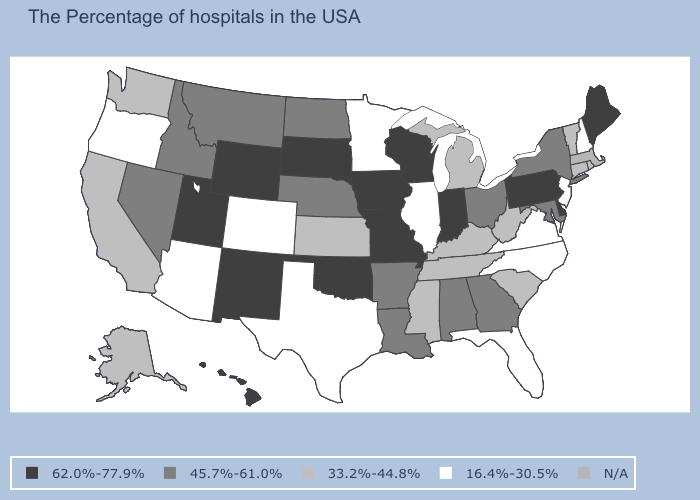Name the states that have a value in the range 45.7%-61.0%?
Be succinct. New York, Maryland, Ohio, Georgia, Alabama, Louisiana, Arkansas, Nebraska, North Dakota, Montana, Idaho, Nevada. Which states have the lowest value in the USA?
Answer briefly. New Hampshire, New Jersey, Virginia, North Carolina, Florida, Illinois, Minnesota, Texas, Colorado, Arizona, Oregon. Which states have the lowest value in the USA?
Short answer required. New Hampshire, New Jersey, Virginia, North Carolina, Florida, Illinois, Minnesota, Texas, Colorado, Arizona, Oregon. What is the value of New Mexico?
Be succinct. 62.0%-77.9%. What is the value of Colorado?
Give a very brief answer. 16.4%-30.5%. What is the value of Virginia?
Give a very brief answer. 16.4%-30.5%. What is the value of Ohio?
Be succinct. 45.7%-61.0%. Name the states that have a value in the range 33.2%-44.8%?
Answer briefly. Rhode Island, Vermont, Connecticut, South Carolina, West Virginia, Michigan, Kentucky, Tennessee, Mississippi, Kansas, California, Washington, Alaska. Name the states that have a value in the range N/A?
Answer briefly. Massachusetts. Name the states that have a value in the range 33.2%-44.8%?
Quick response, please. Rhode Island, Vermont, Connecticut, South Carolina, West Virginia, Michigan, Kentucky, Tennessee, Mississippi, Kansas, California, Washington, Alaska. What is the value of California?
Write a very short answer. 33.2%-44.8%. Which states have the lowest value in the USA?
Be succinct. New Hampshire, New Jersey, Virginia, North Carolina, Florida, Illinois, Minnesota, Texas, Colorado, Arizona, Oregon. Name the states that have a value in the range 16.4%-30.5%?
Concise answer only. New Hampshire, New Jersey, Virginia, North Carolina, Florida, Illinois, Minnesota, Texas, Colorado, Arizona, Oregon. What is the value of Minnesota?
Be succinct. 16.4%-30.5%. 